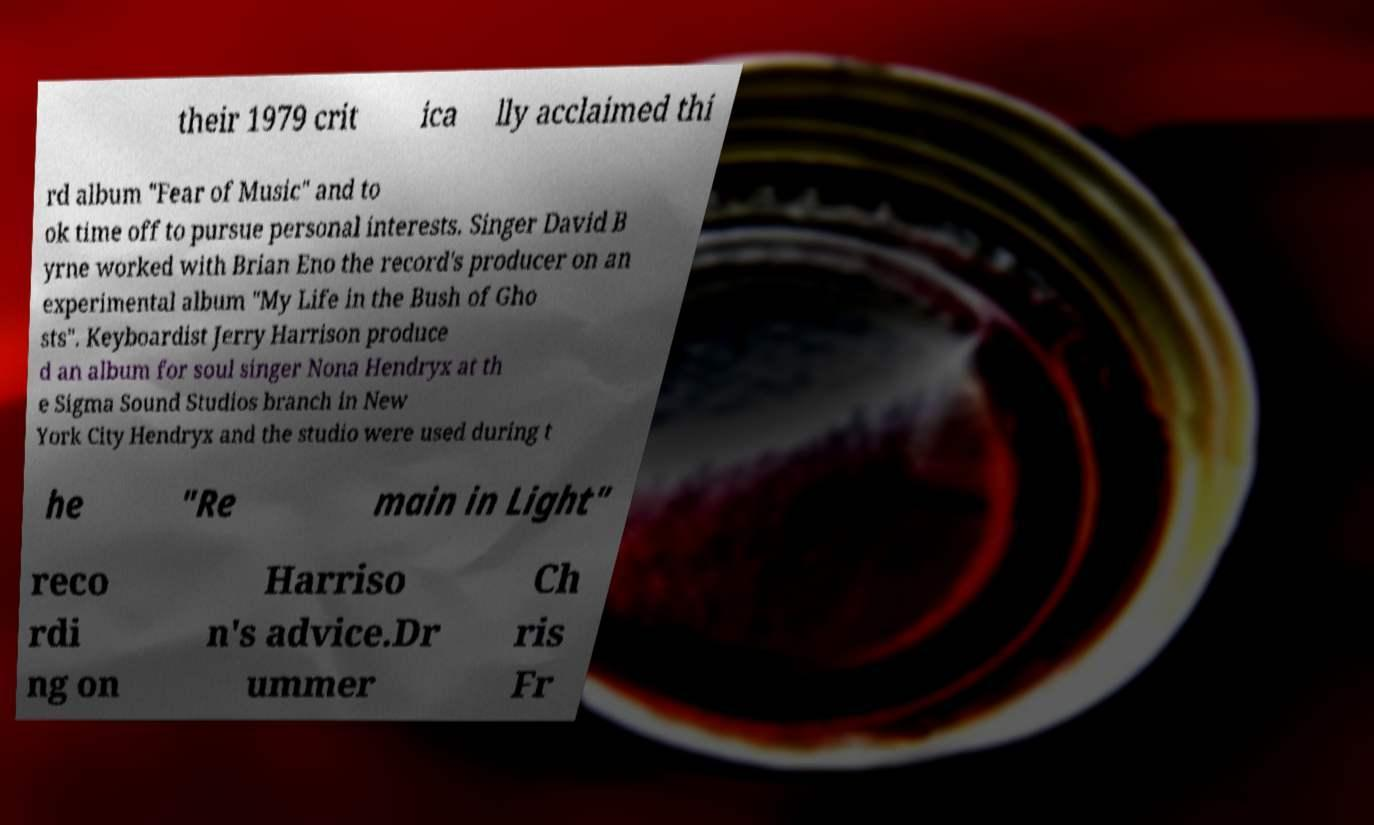Could you extract and type out the text from this image? their 1979 crit ica lly acclaimed thi rd album "Fear of Music" and to ok time off to pursue personal interests. Singer David B yrne worked with Brian Eno the record's producer on an experimental album "My Life in the Bush of Gho sts". Keyboardist Jerry Harrison produce d an album for soul singer Nona Hendryx at th e Sigma Sound Studios branch in New York City Hendryx and the studio were used during t he "Re main in Light" reco rdi ng on Harriso n's advice.Dr ummer Ch ris Fr 